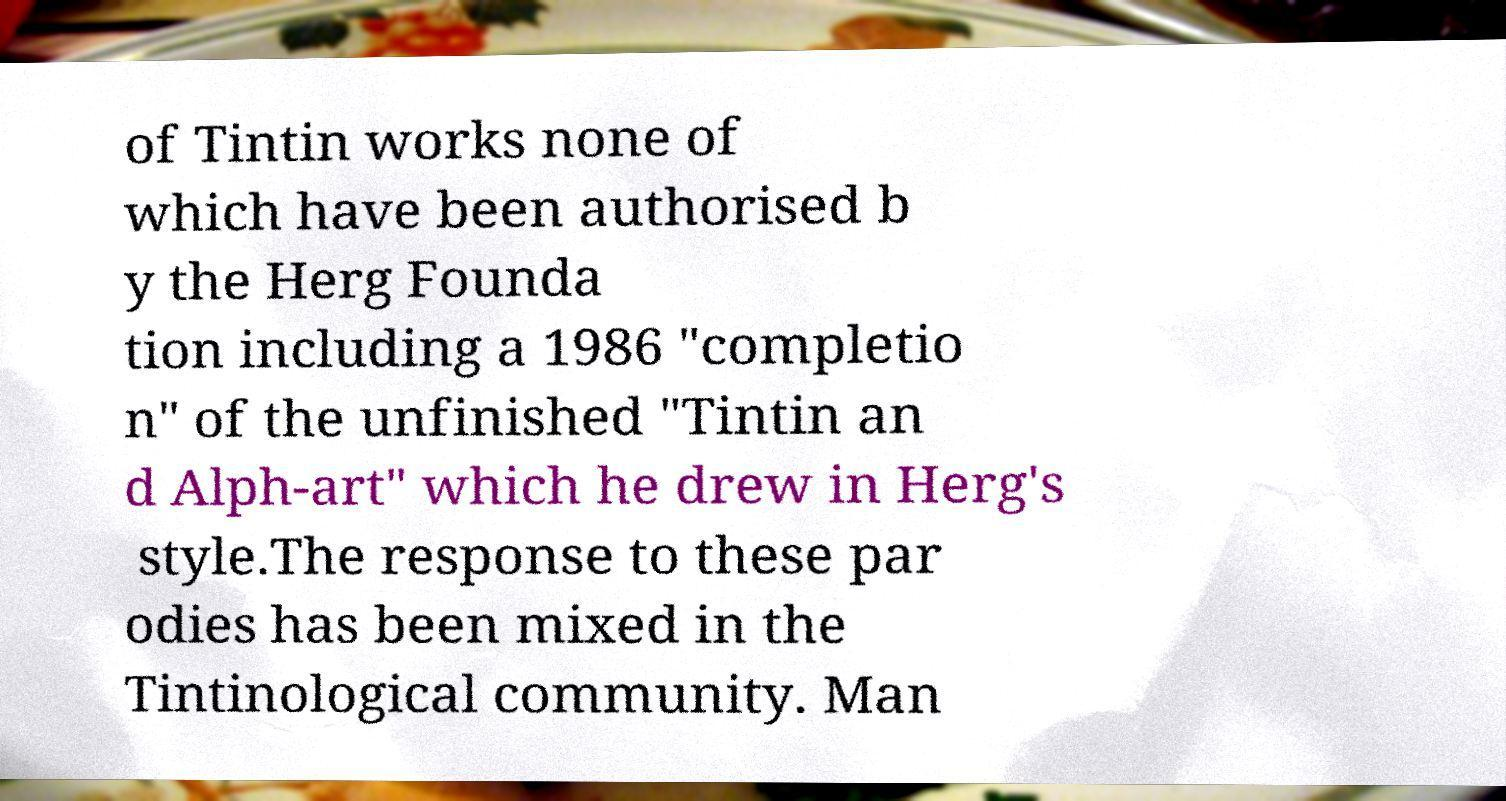Could you extract and type out the text from this image? of Tintin works none of which have been authorised b y the Herg Founda tion including a 1986 "completio n" of the unfinished "Tintin an d Alph-art" which he drew in Herg's style.The response to these par odies has been mixed in the Tintinological community. Man 